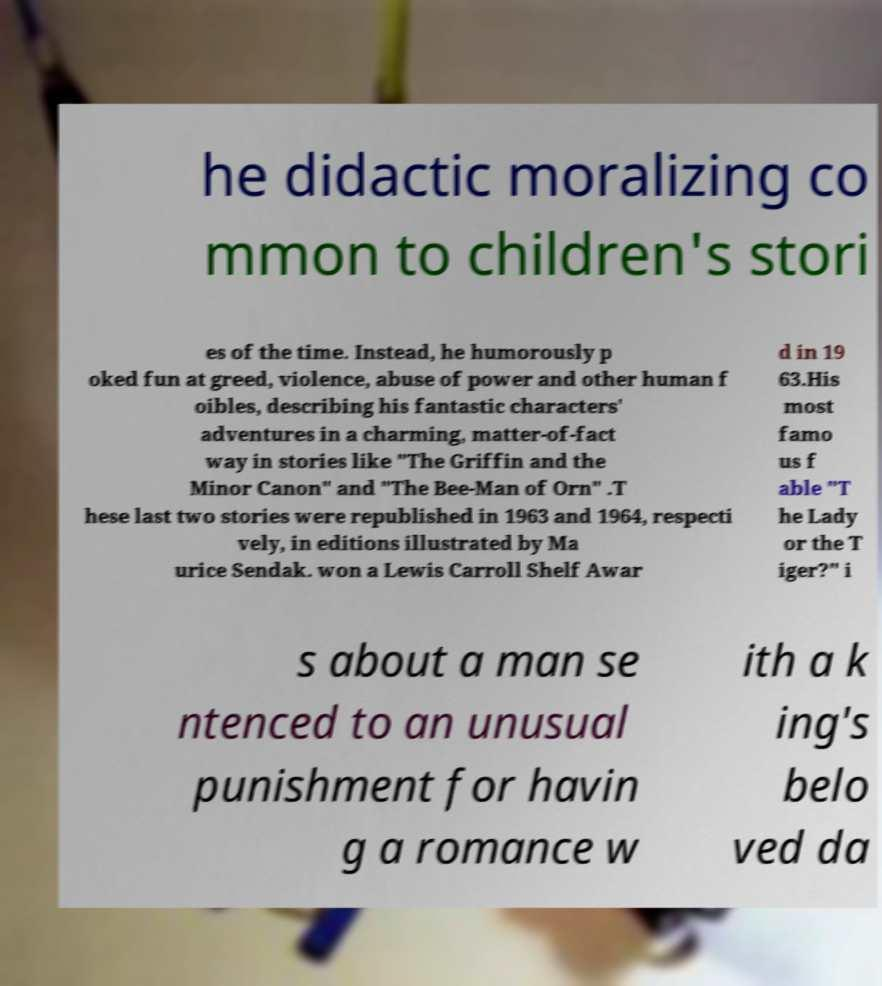There's text embedded in this image that I need extracted. Can you transcribe it verbatim? he didactic moralizing co mmon to children's stori es of the time. Instead, he humorously p oked fun at greed, violence, abuse of power and other human f oibles, describing his fantastic characters' adventures in a charming, matter-of-fact way in stories like "The Griffin and the Minor Canon" and "The Bee-Man of Orn" .T hese last two stories were republished in 1963 and 1964, respecti vely, in editions illustrated by Ma urice Sendak. won a Lewis Carroll Shelf Awar d in 19 63.His most famo us f able "T he Lady or the T iger?" i s about a man se ntenced to an unusual punishment for havin g a romance w ith a k ing's belo ved da 